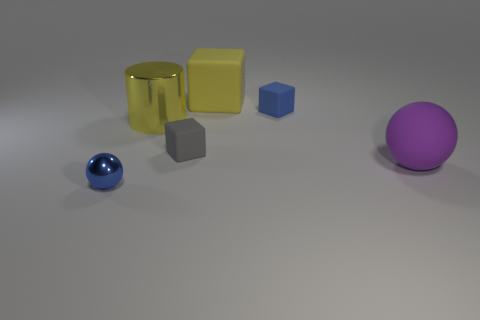There is a metallic object in front of the purple matte object; is there a large matte cube behind it?
Provide a succinct answer. Yes. Is the tiny gray thing made of the same material as the big purple thing?
Ensure brevity in your answer.  Yes. What is the shape of the matte object that is both in front of the yellow cylinder and left of the big purple matte ball?
Your response must be concise. Cube. How big is the sphere that is to the left of the ball right of the blue metallic object?
Your response must be concise. Small. What number of other small things have the same shape as the purple rubber thing?
Ensure brevity in your answer.  1. Do the large shiny cylinder and the big cube have the same color?
Provide a succinct answer. Yes. Are there any other things that have the same shape as the big yellow metallic object?
Give a very brief answer. No. Is there a block that has the same color as the big shiny cylinder?
Make the answer very short. Yes. Does the blue object to the right of the cylinder have the same material as the object in front of the big rubber ball?
Keep it short and to the point. No. What is the color of the large cylinder?
Offer a terse response. Yellow. 